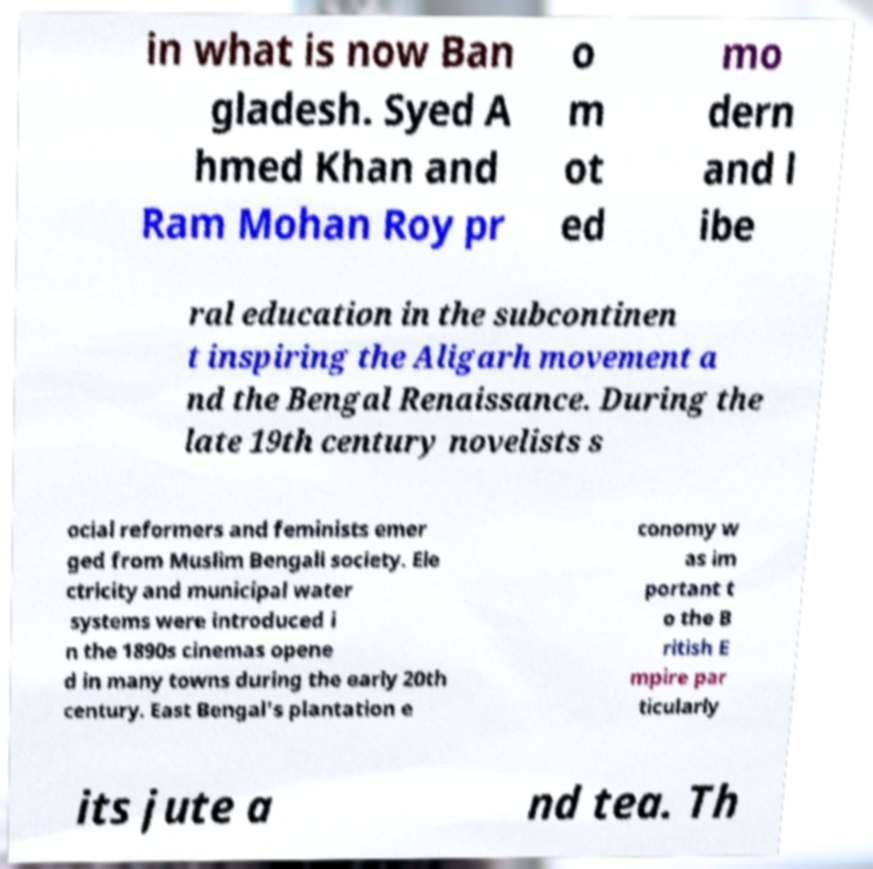Please read and relay the text visible in this image. What does it say? in what is now Ban gladesh. Syed A hmed Khan and Ram Mohan Roy pr o m ot ed mo dern and l ibe ral education in the subcontinen t inspiring the Aligarh movement a nd the Bengal Renaissance. During the late 19th century novelists s ocial reformers and feminists emer ged from Muslim Bengali society. Ele ctricity and municipal water systems were introduced i n the 1890s cinemas opene d in many towns during the early 20th century. East Bengal's plantation e conomy w as im portant t o the B ritish E mpire par ticularly its jute a nd tea. Th 